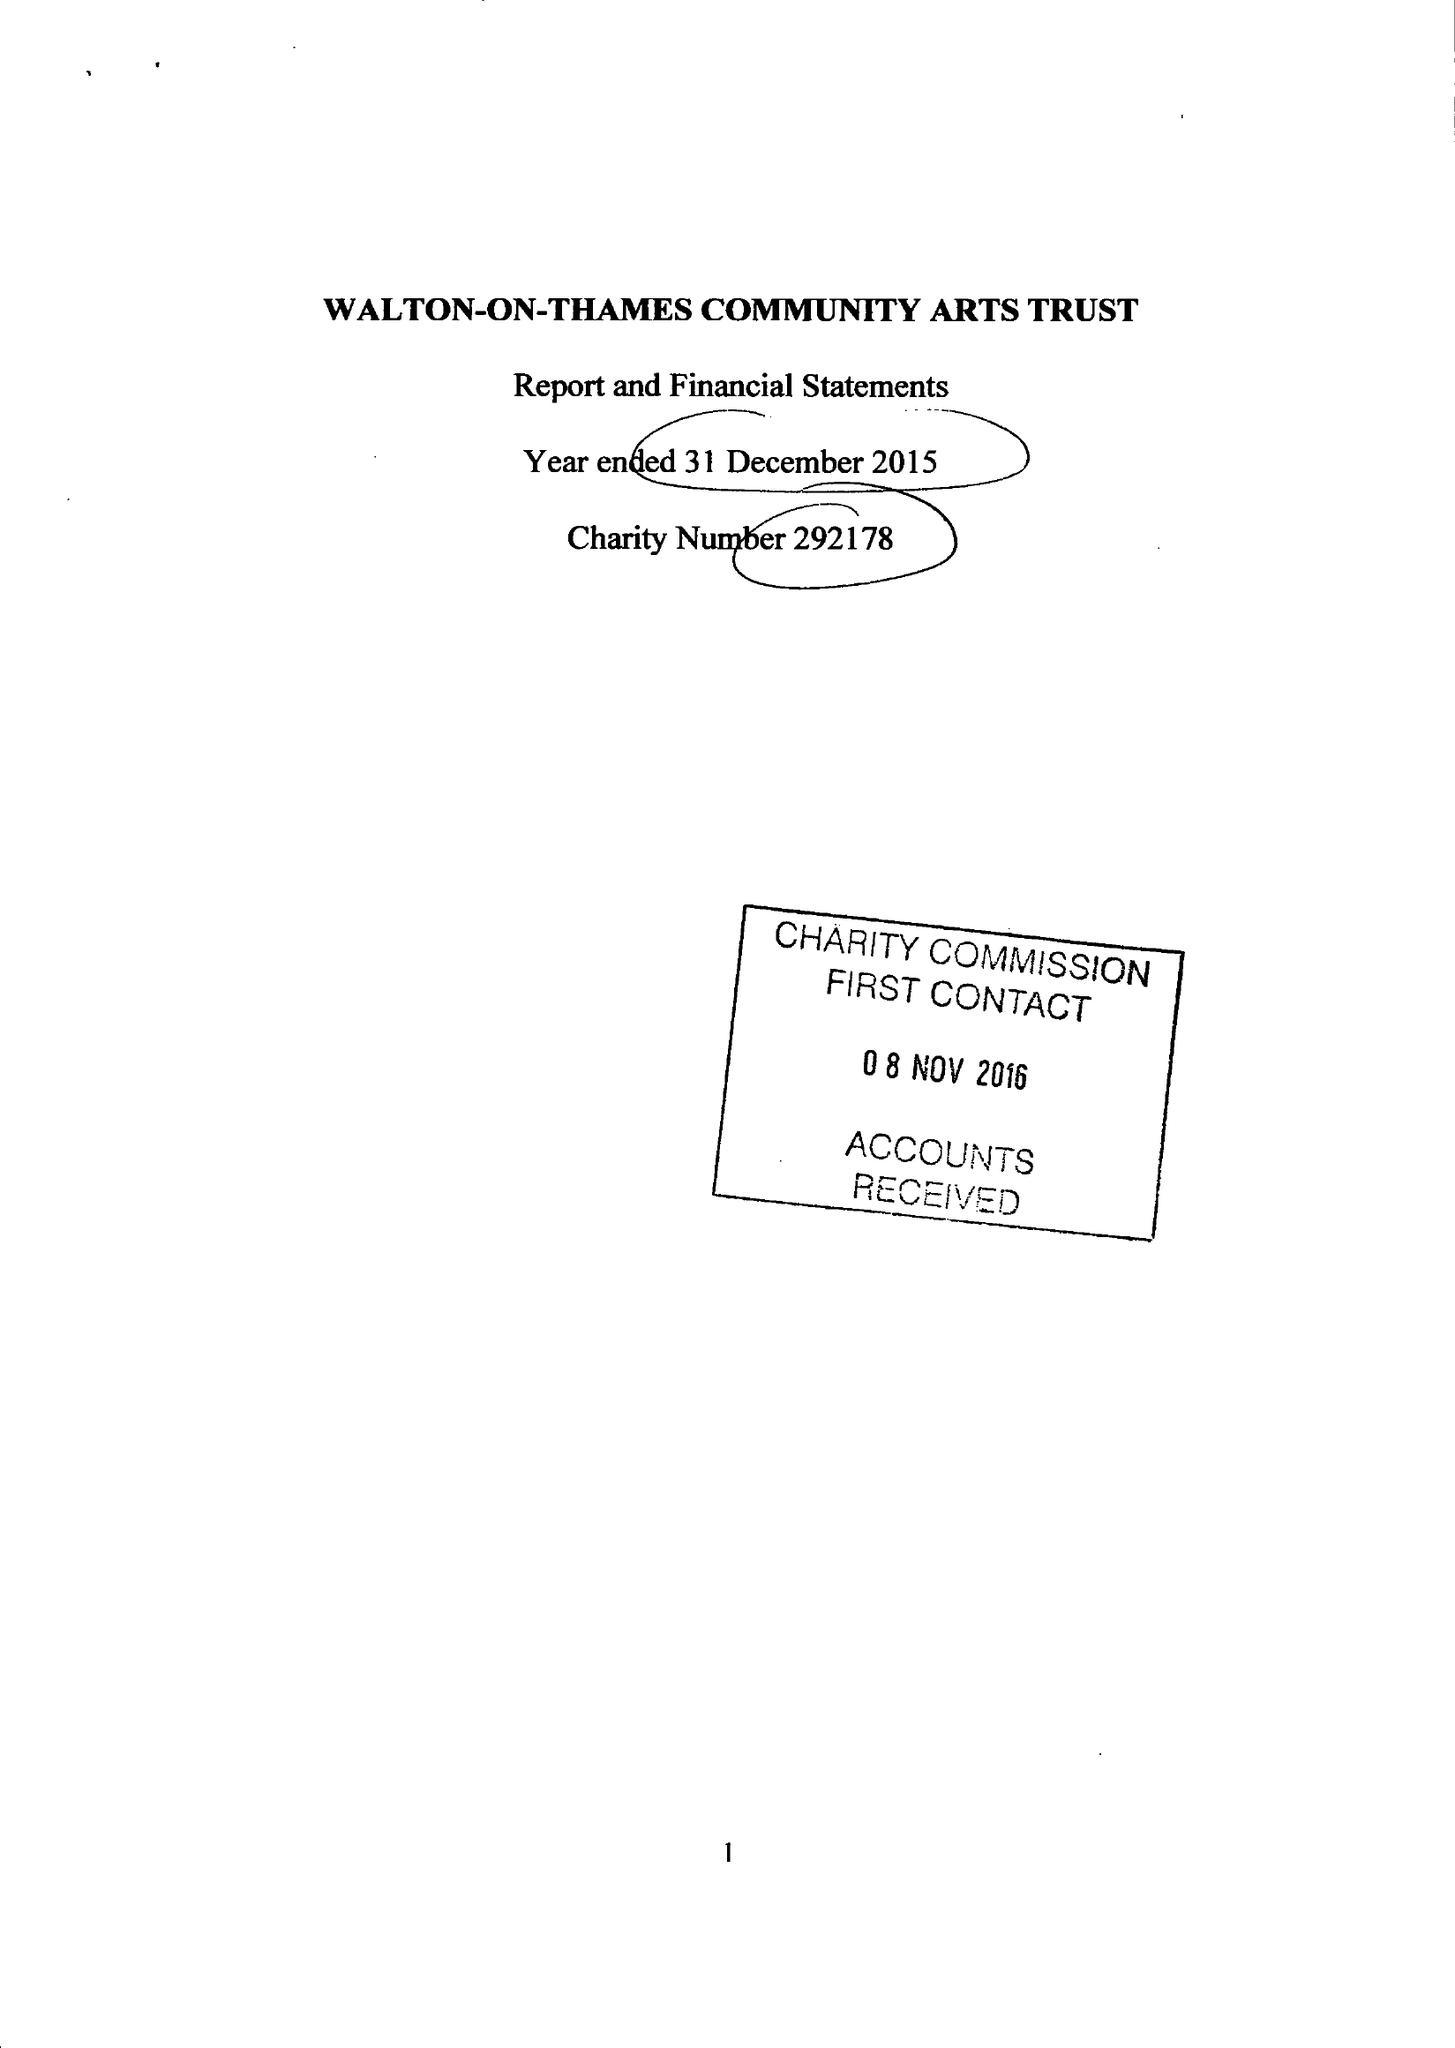What is the value for the address__postcode?
Answer the question using a single word or phrase. KT12 2PR 